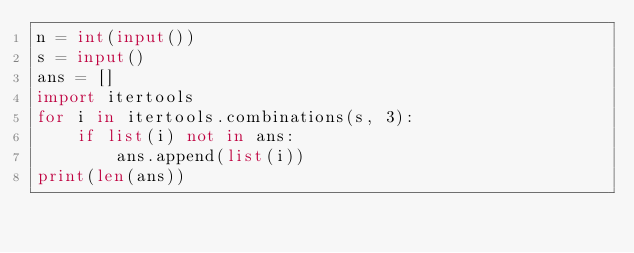Convert code to text. <code><loc_0><loc_0><loc_500><loc_500><_Python_>n = int(input())
s = input()
ans = []
import itertools
for i in itertools.combinations(s, 3):
    if list(i) not in ans:
        ans.append(list(i))
print(len(ans))</code> 